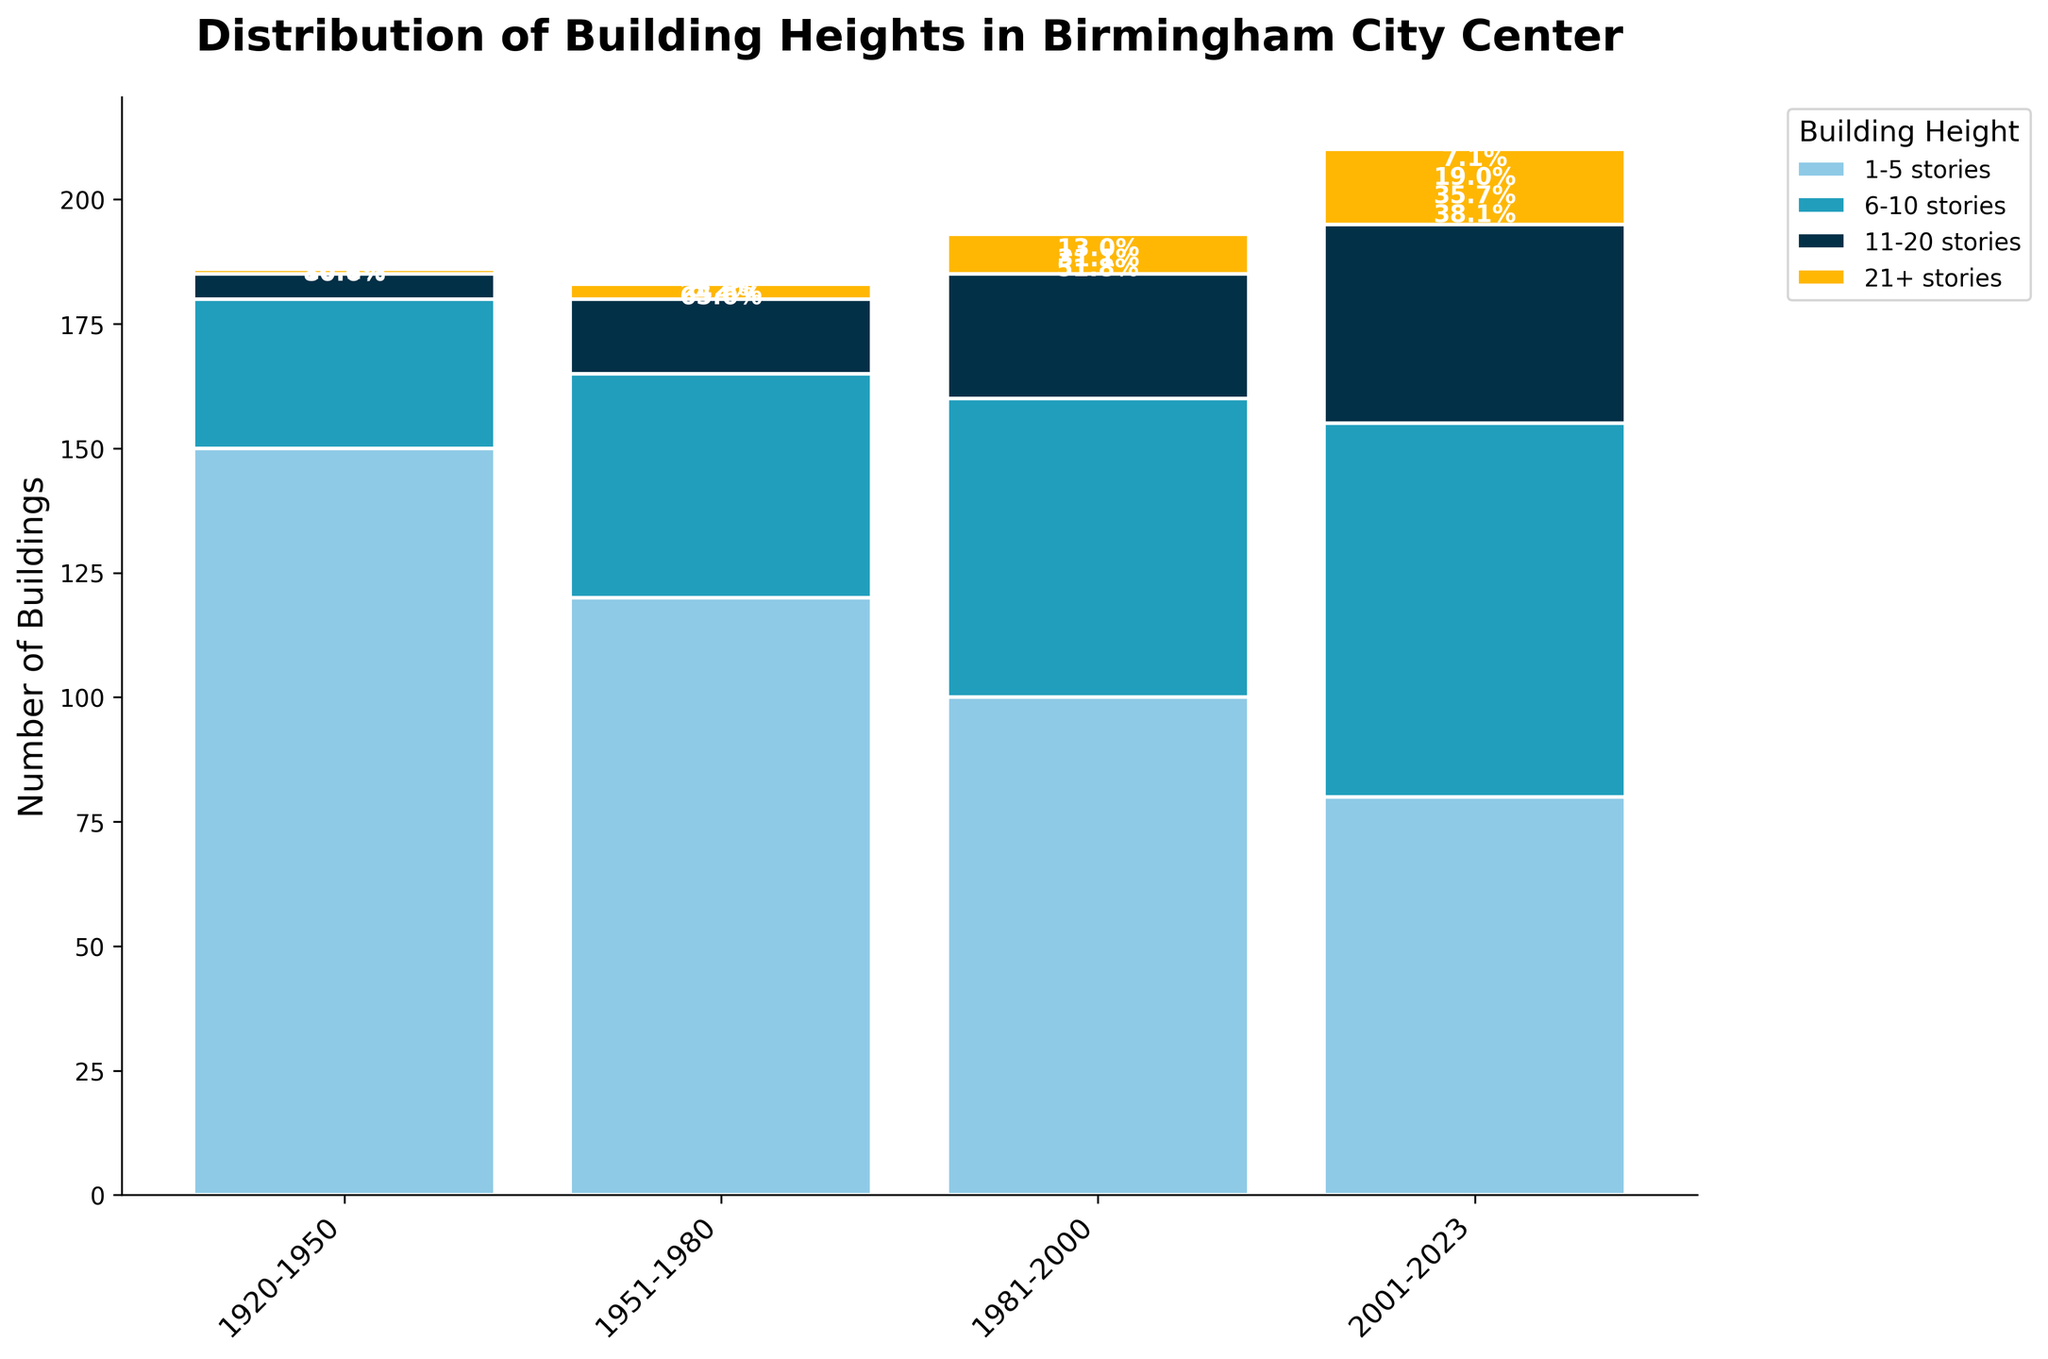What is the title of the figure? The title is located at the top of the figure. It reads "Distribution of Building Heights in Birmingham City Center."
Answer: "Distribution of Building Heights in Birmingham City Center" How many stories are included in the 21+ stories category? There are four distinct colors indicating different categories. The label shows "21+ stories" as the highest category.
Answer: 21+ stories Which time period has the highest total number of buildings? Observe the height of the stacked bars for each time period, the tallest bar represents the time period with the most buildings.
Answer: 1920-1950 Has the number of 1-5-story buildings increased or decreased over the centuries? Check the bar segment color assigned to 1-5 stories. Follow the changes in height over the four time periods.
Answer: Decreased During the 2001-2023 period, what percentage does the 11-20 stories category occupy? Identify the bar segment for 2001-2023 period. The text inside the segment for 11-20 stories shows the percentage.
Answer: 20% Which building height category has seen the most growth since the 1920-1950 period? Compare the height increase of each bar segment from the 1920-1950 period to the 2001-2023 period.
Answer: 21+ stories What is the trend for buildings in the 6-10 stories category over the last century? Observe the bar segment color for 6-10 stories and track its change in height over the four periods.
Answer: Increasing How many more buildings of 6-10 stories were built in 2001-2023 compared to 1951-1980? Subtract the number of 6-10 story buildings in 1951-1980 from that in 2001-2023.
Answer: 30 Between the 1981-2000 and 2001-2023 periods, how has the number of 21+ story buildings changed? Compare the height of the 21+ stories segment between the two periods.
Answer: Increased by 7 What is the proportion of 1-5 story buildings to the total number of buildings in the 1951-1980 period? Sum all segment heights in 1951-1980, then divide the height of the 1-5 stories segment by this total and convert it to a percentage.
Answer: Approximately 57.1% 